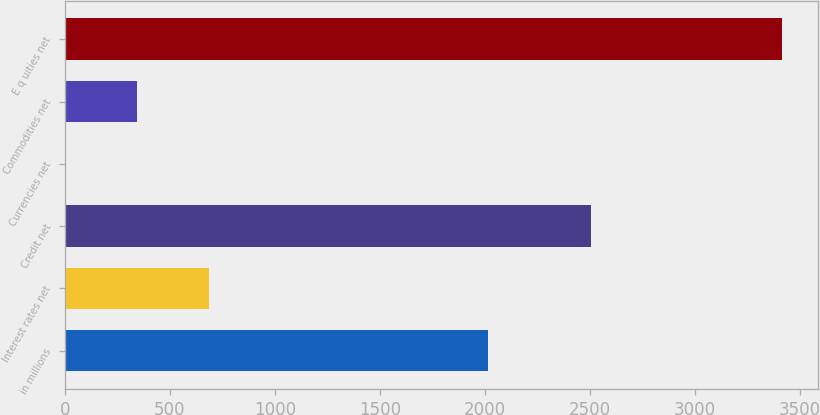Convert chart to OTSL. <chart><loc_0><loc_0><loc_500><loc_500><bar_chart><fcel>in millions<fcel>Interest rates net<fcel>Credit net<fcel>Currencies net<fcel>Commodities net<fcel>E q uities net<nl><fcel>2016<fcel>685.6<fcel>2504<fcel>3<fcel>344.3<fcel>3416<nl></chart> 